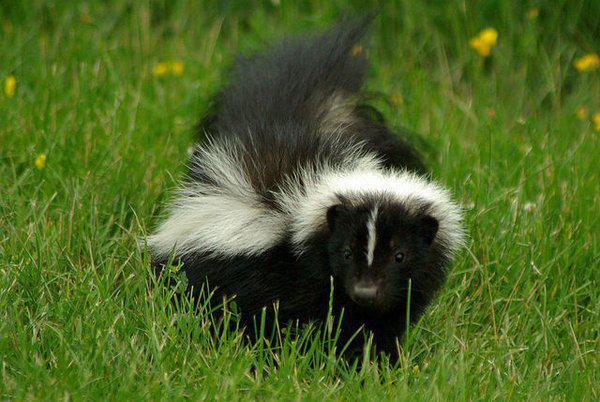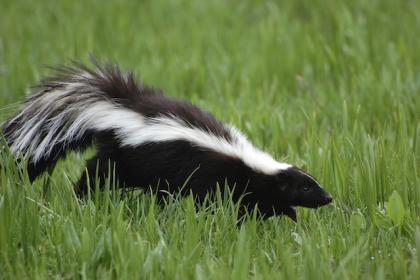The first image is the image on the left, the second image is the image on the right. For the images displayed, is the sentence "Both skunks are facing right." factually correct? Answer yes or no. No. The first image is the image on the left, the second image is the image on the right. Assess this claim about the two images: "there is a skunk in the grass with dandelions growing in the grass". Correct or not? Answer yes or no. Yes. 